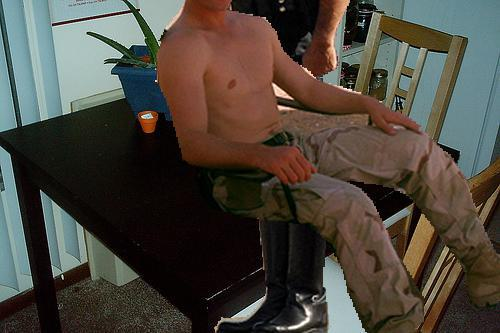What is the person in the image doing? The person appears to be sitting on a chair at the dining table with a relaxed or casual posture, perhaps having a break or engaging in a casual conversation. 